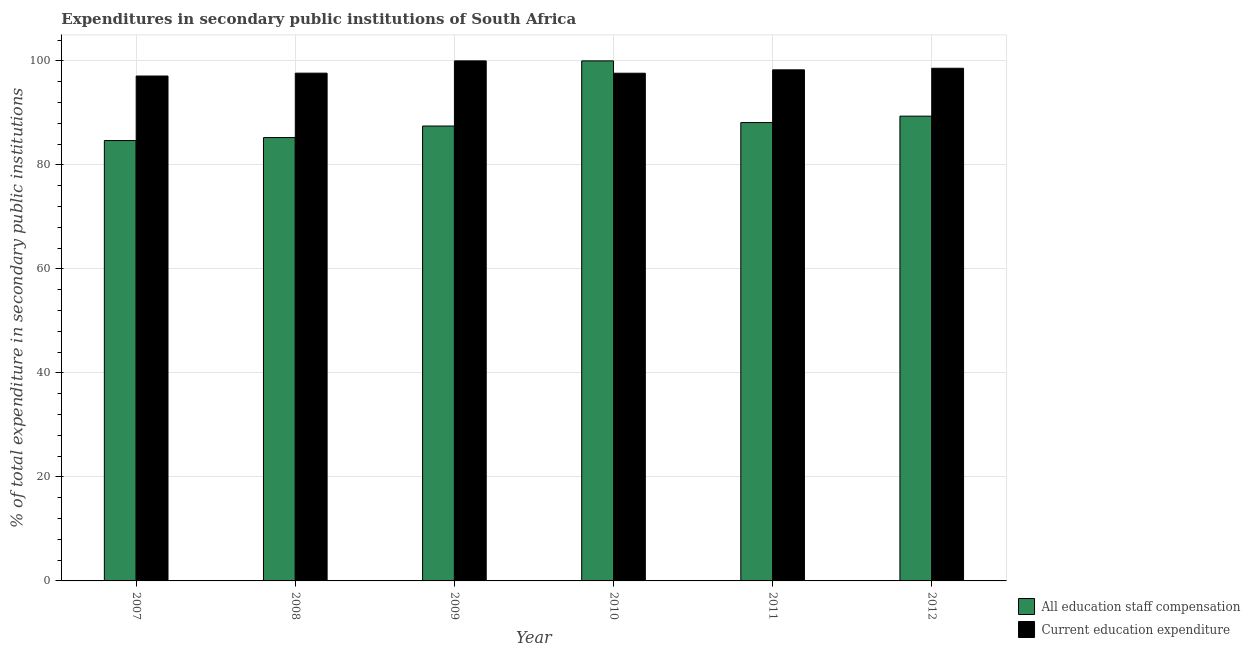Are the number of bars per tick equal to the number of legend labels?
Your answer should be compact. Yes. Are the number of bars on each tick of the X-axis equal?
Offer a terse response. Yes. How many bars are there on the 5th tick from the right?
Your answer should be very brief. 2. What is the expenditure in staff compensation in 2012?
Your answer should be very brief. 89.37. Across all years, what is the minimum expenditure in education?
Provide a succinct answer. 97.09. In which year was the expenditure in education maximum?
Your answer should be very brief. 2009. What is the total expenditure in education in the graph?
Make the answer very short. 589.21. What is the difference between the expenditure in staff compensation in 2008 and that in 2012?
Your answer should be very brief. -4.12. What is the difference between the expenditure in staff compensation in 2011 and the expenditure in education in 2007?
Provide a succinct answer. 3.46. What is the average expenditure in education per year?
Offer a very short reply. 98.2. In the year 2007, what is the difference between the expenditure in staff compensation and expenditure in education?
Provide a succinct answer. 0. What is the ratio of the expenditure in education in 2007 to that in 2008?
Your answer should be very brief. 0.99. Is the expenditure in education in 2008 less than that in 2010?
Your answer should be compact. No. Is the difference between the expenditure in staff compensation in 2010 and 2011 greater than the difference between the expenditure in education in 2010 and 2011?
Make the answer very short. No. What is the difference between the highest and the second highest expenditure in education?
Keep it short and to the point. 1.42. What is the difference between the highest and the lowest expenditure in education?
Give a very brief answer. 2.91. In how many years, is the expenditure in staff compensation greater than the average expenditure in staff compensation taken over all years?
Provide a short and direct response. 2. Is the sum of the expenditure in staff compensation in 2007 and 2011 greater than the maximum expenditure in education across all years?
Your answer should be compact. Yes. What does the 1st bar from the left in 2007 represents?
Your answer should be compact. All education staff compensation. What does the 2nd bar from the right in 2007 represents?
Keep it short and to the point. All education staff compensation. How many bars are there?
Keep it short and to the point. 12. What is the difference between two consecutive major ticks on the Y-axis?
Offer a very short reply. 20. How many legend labels are there?
Your response must be concise. 2. How are the legend labels stacked?
Provide a succinct answer. Vertical. What is the title of the graph?
Ensure brevity in your answer.  Expenditures in secondary public institutions of South Africa. Does "Non-pregnant women" appear as one of the legend labels in the graph?
Provide a succinct answer. No. What is the label or title of the X-axis?
Provide a short and direct response. Year. What is the label or title of the Y-axis?
Your response must be concise. % of total expenditure in secondary public institutions. What is the % of total expenditure in secondary public institutions in All education staff compensation in 2007?
Give a very brief answer. 84.68. What is the % of total expenditure in secondary public institutions in Current education expenditure in 2007?
Ensure brevity in your answer.  97.09. What is the % of total expenditure in secondary public institutions of All education staff compensation in 2008?
Provide a succinct answer. 85.25. What is the % of total expenditure in secondary public institutions of Current education expenditure in 2008?
Keep it short and to the point. 97.64. What is the % of total expenditure in secondary public institutions of All education staff compensation in 2009?
Provide a short and direct response. 87.47. What is the % of total expenditure in secondary public institutions in Current education expenditure in 2009?
Make the answer very short. 100. What is the % of total expenditure in secondary public institutions of All education staff compensation in 2010?
Offer a very short reply. 100. What is the % of total expenditure in secondary public institutions of Current education expenditure in 2010?
Keep it short and to the point. 97.63. What is the % of total expenditure in secondary public institutions in All education staff compensation in 2011?
Provide a short and direct response. 88.14. What is the % of total expenditure in secondary public institutions of Current education expenditure in 2011?
Ensure brevity in your answer.  98.28. What is the % of total expenditure in secondary public institutions of All education staff compensation in 2012?
Keep it short and to the point. 89.37. What is the % of total expenditure in secondary public institutions in Current education expenditure in 2012?
Offer a very short reply. 98.58. Across all years, what is the maximum % of total expenditure in secondary public institutions in All education staff compensation?
Offer a terse response. 100. Across all years, what is the maximum % of total expenditure in secondary public institutions of Current education expenditure?
Provide a short and direct response. 100. Across all years, what is the minimum % of total expenditure in secondary public institutions in All education staff compensation?
Make the answer very short. 84.68. Across all years, what is the minimum % of total expenditure in secondary public institutions in Current education expenditure?
Your answer should be compact. 97.09. What is the total % of total expenditure in secondary public institutions in All education staff compensation in the graph?
Your answer should be very brief. 534.91. What is the total % of total expenditure in secondary public institutions of Current education expenditure in the graph?
Your answer should be compact. 589.21. What is the difference between the % of total expenditure in secondary public institutions of All education staff compensation in 2007 and that in 2008?
Offer a very short reply. -0.57. What is the difference between the % of total expenditure in secondary public institutions in Current education expenditure in 2007 and that in 2008?
Make the answer very short. -0.55. What is the difference between the % of total expenditure in secondary public institutions in All education staff compensation in 2007 and that in 2009?
Make the answer very short. -2.79. What is the difference between the % of total expenditure in secondary public institutions of Current education expenditure in 2007 and that in 2009?
Provide a short and direct response. -2.91. What is the difference between the % of total expenditure in secondary public institutions of All education staff compensation in 2007 and that in 2010?
Keep it short and to the point. -15.32. What is the difference between the % of total expenditure in secondary public institutions of Current education expenditure in 2007 and that in 2010?
Give a very brief answer. -0.54. What is the difference between the % of total expenditure in secondary public institutions in All education staff compensation in 2007 and that in 2011?
Your answer should be compact. -3.46. What is the difference between the % of total expenditure in secondary public institutions of Current education expenditure in 2007 and that in 2011?
Ensure brevity in your answer.  -1.19. What is the difference between the % of total expenditure in secondary public institutions of All education staff compensation in 2007 and that in 2012?
Your response must be concise. -4.69. What is the difference between the % of total expenditure in secondary public institutions of Current education expenditure in 2007 and that in 2012?
Your response must be concise. -1.49. What is the difference between the % of total expenditure in secondary public institutions in All education staff compensation in 2008 and that in 2009?
Your response must be concise. -2.22. What is the difference between the % of total expenditure in secondary public institutions of Current education expenditure in 2008 and that in 2009?
Give a very brief answer. -2.36. What is the difference between the % of total expenditure in secondary public institutions of All education staff compensation in 2008 and that in 2010?
Provide a short and direct response. -14.75. What is the difference between the % of total expenditure in secondary public institutions in Current education expenditure in 2008 and that in 2010?
Your response must be concise. 0.01. What is the difference between the % of total expenditure in secondary public institutions of All education staff compensation in 2008 and that in 2011?
Provide a short and direct response. -2.89. What is the difference between the % of total expenditure in secondary public institutions of Current education expenditure in 2008 and that in 2011?
Ensure brevity in your answer.  -0.64. What is the difference between the % of total expenditure in secondary public institutions in All education staff compensation in 2008 and that in 2012?
Provide a short and direct response. -4.12. What is the difference between the % of total expenditure in secondary public institutions of Current education expenditure in 2008 and that in 2012?
Your answer should be compact. -0.94. What is the difference between the % of total expenditure in secondary public institutions of All education staff compensation in 2009 and that in 2010?
Your response must be concise. -12.53. What is the difference between the % of total expenditure in secondary public institutions of Current education expenditure in 2009 and that in 2010?
Your answer should be very brief. 2.37. What is the difference between the % of total expenditure in secondary public institutions of All education staff compensation in 2009 and that in 2011?
Give a very brief answer. -0.66. What is the difference between the % of total expenditure in secondary public institutions in Current education expenditure in 2009 and that in 2011?
Keep it short and to the point. 1.72. What is the difference between the % of total expenditure in secondary public institutions in All education staff compensation in 2009 and that in 2012?
Ensure brevity in your answer.  -1.9. What is the difference between the % of total expenditure in secondary public institutions of Current education expenditure in 2009 and that in 2012?
Your answer should be very brief. 1.42. What is the difference between the % of total expenditure in secondary public institutions in All education staff compensation in 2010 and that in 2011?
Your answer should be compact. 11.86. What is the difference between the % of total expenditure in secondary public institutions of Current education expenditure in 2010 and that in 2011?
Provide a short and direct response. -0.65. What is the difference between the % of total expenditure in secondary public institutions in All education staff compensation in 2010 and that in 2012?
Make the answer very short. 10.63. What is the difference between the % of total expenditure in secondary public institutions in Current education expenditure in 2010 and that in 2012?
Ensure brevity in your answer.  -0.95. What is the difference between the % of total expenditure in secondary public institutions in All education staff compensation in 2011 and that in 2012?
Offer a terse response. -1.24. What is the difference between the % of total expenditure in secondary public institutions in Current education expenditure in 2011 and that in 2012?
Your answer should be very brief. -0.3. What is the difference between the % of total expenditure in secondary public institutions of All education staff compensation in 2007 and the % of total expenditure in secondary public institutions of Current education expenditure in 2008?
Offer a terse response. -12.96. What is the difference between the % of total expenditure in secondary public institutions of All education staff compensation in 2007 and the % of total expenditure in secondary public institutions of Current education expenditure in 2009?
Offer a very short reply. -15.32. What is the difference between the % of total expenditure in secondary public institutions of All education staff compensation in 2007 and the % of total expenditure in secondary public institutions of Current education expenditure in 2010?
Provide a succinct answer. -12.95. What is the difference between the % of total expenditure in secondary public institutions in All education staff compensation in 2007 and the % of total expenditure in secondary public institutions in Current education expenditure in 2011?
Make the answer very short. -13.6. What is the difference between the % of total expenditure in secondary public institutions in All education staff compensation in 2007 and the % of total expenditure in secondary public institutions in Current education expenditure in 2012?
Your answer should be very brief. -13.9. What is the difference between the % of total expenditure in secondary public institutions in All education staff compensation in 2008 and the % of total expenditure in secondary public institutions in Current education expenditure in 2009?
Offer a very short reply. -14.75. What is the difference between the % of total expenditure in secondary public institutions in All education staff compensation in 2008 and the % of total expenditure in secondary public institutions in Current education expenditure in 2010?
Your answer should be compact. -12.38. What is the difference between the % of total expenditure in secondary public institutions in All education staff compensation in 2008 and the % of total expenditure in secondary public institutions in Current education expenditure in 2011?
Offer a terse response. -13.03. What is the difference between the % of total expenditure in secondary public institutions of All education staff compensation in 2008 and the % of total expenditure in secondary public institutions of Current education expenditure in 2012?
Keep it short and to the point. -13.33. What is the difference between the % of total expenditure in secondary public institutions in All education staff compensation in 2009 and the % of total expenditure in secondary public institutions in Current education expenditure in 2010?
Give a very brief answer. -10.15. What is the difference between the % of total expenditure in secondary public institutions of All education staff compensation in 2009 and the % of total expenditure in secondary public institutions of Current education expenditure in 2011?
Keep it short and to the point. -10.8. What is the difference between the % of total expenditure in secondary public institutions in All education staff compensation in 2009 and the % of total expenditure in secondary public institutions in Current education expenditure in 2012?
Offer a very short reply. -11.11. What is the difference between the % of total expenditure in secondary public institutions of All education staff compensation in 2010 and the % of total expenditure in secondary public institutions of Current education expenditure in 2011?
Provide a succinct answer. 1.72. What is the difference between the % of total expenditure in secondary public institutions in All education staff compensation in 2010 and the % of total expenditure in secondary public institutions in Current education expenditure in 2012?
Ensure brevity in your answer.  1.42. What is the difference between the % of total expenditure in secondary public institutions of All education staff compensation in 2011 and the % of total expenditure in secondary public institutions of Current education expenditure in 2012?
Keep it short and to the point. -10.45. What is the average % of total expenditure in secondary public institutions in All education staff compensation per year?
Offer a very short reply. 89.15. What is the average % of total expenditure in secondary public institutions in Current education expenditure per year?
Your response must be concise. 98.2. In the year 2007, what is the difference between the % of total expenditure in secondary public institutions of All education staff compensation and % of total expenditure in secondary public institutions of Current education expenditure?
Your answer should be very brief. -12.41. In the year 2008, what is the difference between the % of total expenditure in secondary public institutions in All education staff compensation and % of total expenditure in secondary public institutions in Current education expenditure?
Your answer should be compact. -12.39. In the year 2009, what is the difference between the % of total expenditure in secondary public institutions of All education staff compensation and % of total expenditure in secondary public institutions of Current education expenditure?
Give a very brief answer. -12.53. In the year 2010, what is the difference between the % of total expenditure in secondary public institutions in All education staff compensation and % of total expenditure in secondary public institutions in Current education expenditure?
Your answer should be compact. 2.37. In the year 2011, what is the difference between the % of total expenditure in secondary public institutions of All education staff compensation and % of total expenditure in secondary public institutions of Current education expenditure?
Your answer should be very brief. -10.14. In the year 2012, what is the difference between the % of total expenditure in secondary public institutions of All education staff compensation and % of total expenditure in secondary public institutions of Current education expenditure?
Provide a succinct answer. -9.21. What is the ratio of the % of total expenditure in secondary public institutions in All education staff compensation in 2007 to that in 2008?
Offer a terse response. 0.99. What is the ratio of the % of total expenditure in secondary public institutions in Current education expenditure in 2007 to that in 2008?
Offer a terse response. 0.99. What is the ratio of the % of total expenditure in secondary public institutions in All education staff compensation in 2007 to that in 2009?
Keep it short and to the point. 0.97. What is the ratio of the % of total expenditure in secondary public institutions of Current education expenditure in 2007 to that in 2009?
Provide a succinct answer. 0.97. What is the ratio of the % of total expenditure in secondary public institutions in All education staff compensation in 2007 to that in 2010?
Give a very brief answer. 0.85. What is the ratio of the % of total expenditure in secondary public institutions in Current education expenditure in 2007 to that in 2010?
Keep it short and to the point. 0.99. What is the ratio of the % of total expenditure in secondary public institutions of All education staff compensation in 2007 to that in 2011?
Keep it short and to the point. 0.96. What is the ratio of the % of total expenditure in secondary public institutions in Current education expenditure in 2007 to that in 2011?
Provide a short and direct response. 0.99. What is the ratio of the % of total expenditure in secondary public institutions of All education staff compensation in 2007 to that in 2012?
Provide a succinct answer. 0.95. What is the ratio of the % of total expenditure in secondary public institutions of Current education expenditure in 2007 to that in 2012?
Give a very brief answer. 0.98. What is the ratio of the % of total expenditure in secondary public institutions in All education staff compensation in 2008 to that in 2009?
Offer a very short reply. 0.97. What is the ratio of the % of total expenditure in secondary public institutions of Current education expenditure in 2008 to that in 2009?
Keep it short and to the point. 0.98. What is the ratio of the % of total expenditure in secondary public institutions of All education staff compensation in 2008 to that in 2010?
Offer a terse response. 0.85. What is the ratio of the % of total expenditure in secondary public institutions in Current education expenditure in 2008 to that in 2010?
Keep it short and to the point. 1. What is the ratio of the % of total expenditure in secondary public institutions in All education staff compensation in 2008 to that in 2011?
Your response must be concise. 0.97. What is the ratio of the % of total expenditure in secondary public institutions in All education staff compensation in 2008 to that in 2012?
Your response must be concise. 0.95. What is the ratio of the % of total expenditure in secondary public institutions of All education staff compensation in 2009 to that in 2010?
Offer a terse response. 0.87. What is the ratio of the % of total expenditure in secondary public institutions of Current education expenditure in 2009 to that in 2010?
Your answer should be very brief. 1.02. What is the ratio of the % of total expenditure in secondary public institutions of All education staff compensation in 2009 to that in 2011?
Provide a succinct answer. 0.99. What is the ratio of the % of total expenditure in secondary public institutions of Current education expenditure in 2009 to that in 2011?
Make the answer very short. 1.02. What is the ratio of the % of total expenditure in secondary public institutions in All education staff compensation in 2009 to that in 2012?
Provide a succinct answer. 0.98. What is the ratio of the % of total expenditure in secondary public institutions in Current education expenditure in 2009 to that in 2012?
Make the answer very short. 1.01. What is the ratio of the % of total expenditure in secondary public institutions in All education staff compensation in 2010 to that in 2011?
Keep it short and to the point. 1.13. What is the ratio of the % of total expenditure in secondary public institutions of All education staff compensation in 2010 to that in 2012?
Offer a very short reply. 1.12. What is the ratio of the % of total expenditure in secondary public institutions in Current education expenditure in 2010 to that in 2012?
Offer a terse response. 0.99. What is the ratio of the % of total expenditure in secondary public institutions in All education staff compensation in 2011 to that in 2012?
Your answer should be very brief. 0.99. What is the difference between the highest and the second highest % of total expenditure in secondary public institutions in All education staff compensation?
Your response must be concise. 10.63. What is the difference between the highest and the second highest % of total expenditure in secondary public institutions of Current education expenditure?
Keep it short and to the point. 1.42. What is the difference between the highest and the lowest % of total expenditure in secondary public institutions in All education staff compensation?
Your answer should be very brief. 15.32. What is the difference between the highest and the lowest % of total expenditure in secondary public institutions in Current education expenditure?
Ensure brevity in your answer.  2.91. 